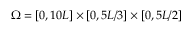<formula> <loc_0><loc_0><loc_500><loc_500>\Omega = [ 0 , 1 0 L ] \times [ 0 , 5 L / 3 ] \times [ 0 , 5 L / 2 ]</formula> 